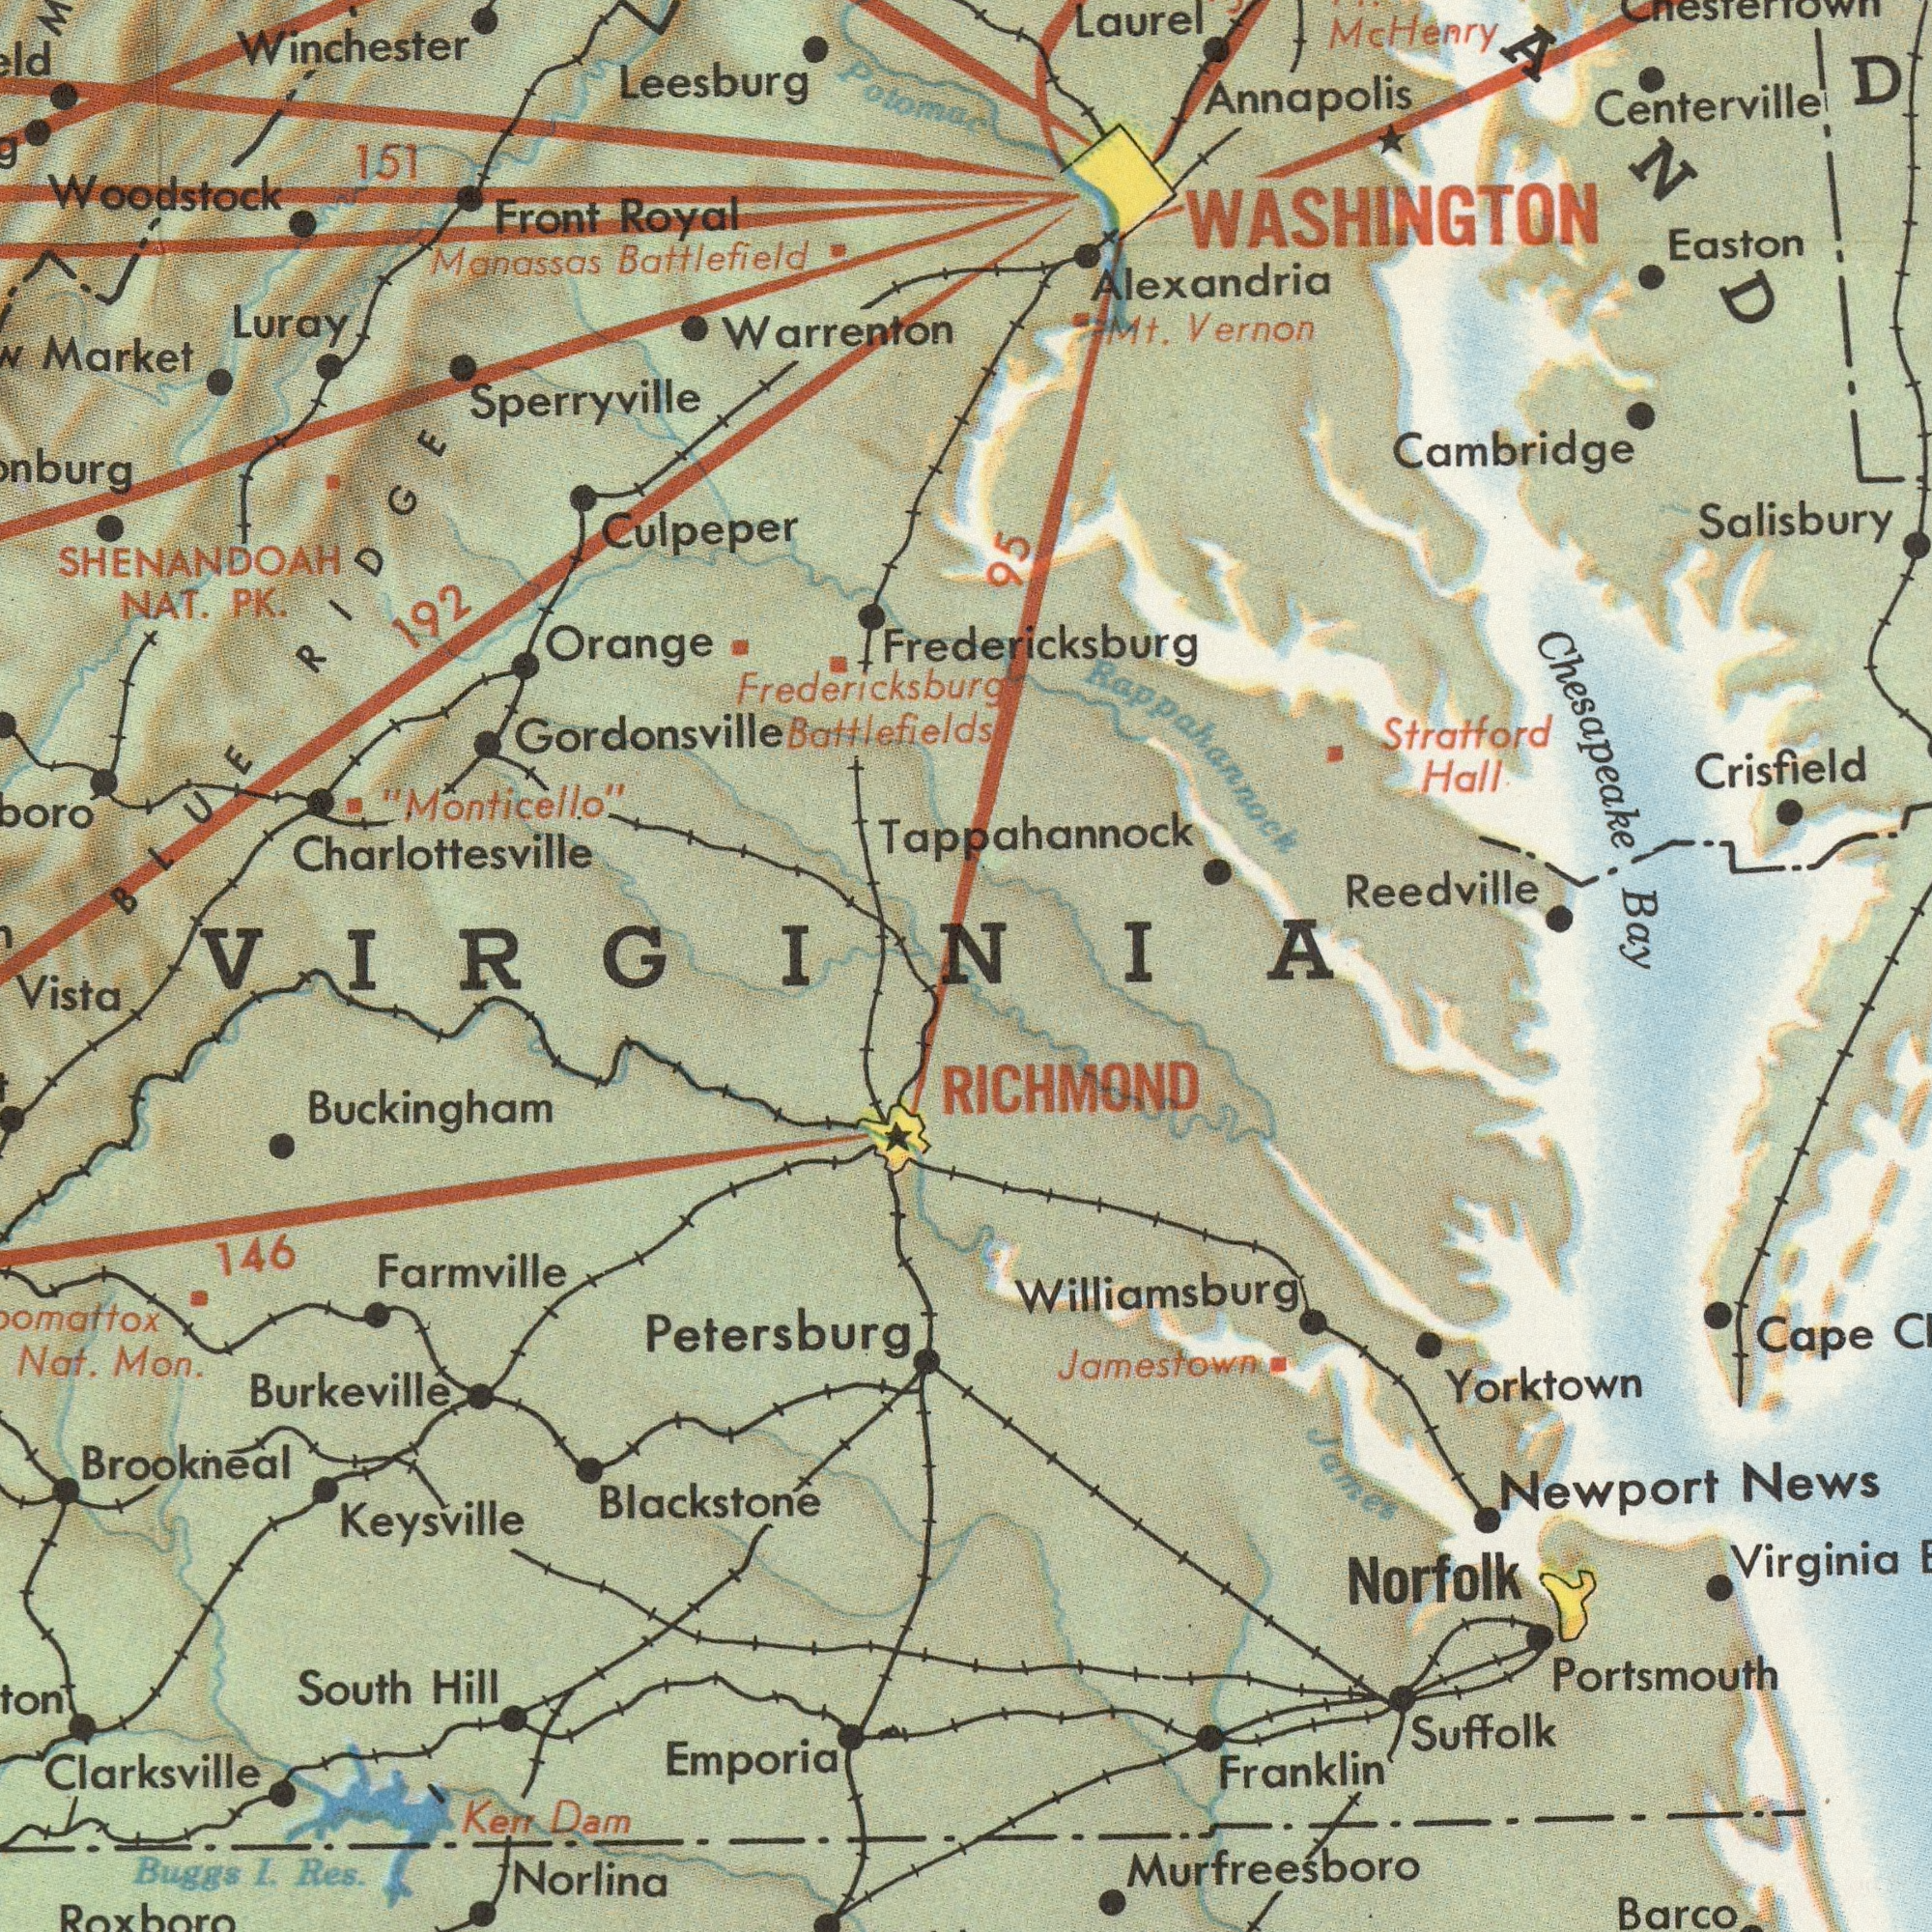What text appears in the bottom-right area of the image? Portsmouth Jamestown Newport Yorktown Suffolk News Norfolk Virginia Murfreesboro Cape Barco RICHMOND Williamsburg James Franklin What text can you see in the bottom-left section? Blackstone Brookneal Keysville Farmville Buckingham Norlina Buggs Clarksville Res. Emporia I. Nat. Mon. South Dam Kerr Petersburg Hill Roxboro 146 Vista Burkeville What text can you see in the top-right section? Salisbury Mc Reedville Annapolis Strafford AND Tappahannock Chesapeake Cambridge Easton Alexandria Bay Fredericksburg Centerville Hall Mt. WASHINGTON Crisfield Vernon Laurel Rappahannock 95 Henry What text can you see in the top-left section? Woodstock Culpeper Leesburg Warrenton Fredericksburg NAT. Front Battlefield "Monticello" Market 192 PK. Luray Charlottesville Manassas Royal 151 SHENANDOAH Gordonsville Winchester Orange Potomac Sperryville BLUE Battlefields RIDGE VIRGINIA 